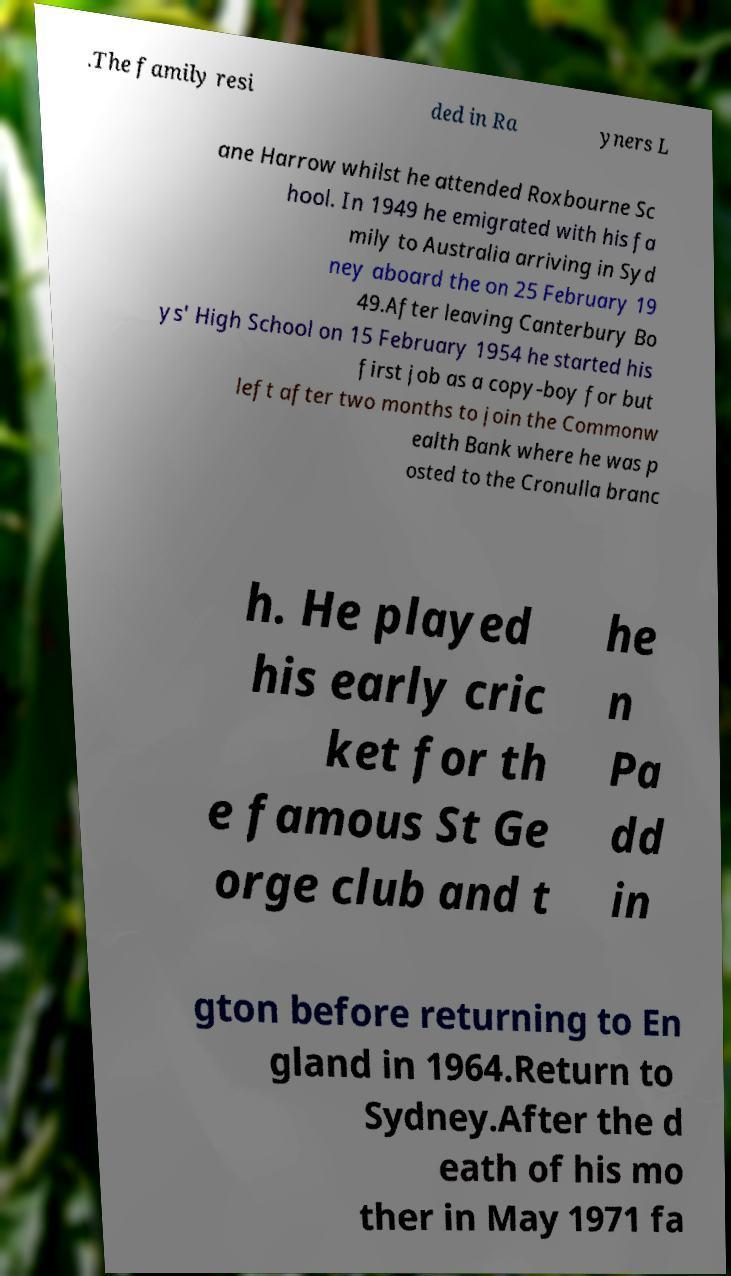What messages or text are displayed in this image? I need them in a readable, typed format. .The family resi ded in Ra yners L ane Harrow whilst he attended Roxbourne Sc hool. In 1949 he emigrated with his fa mily to Australia arriving in Syd ney aboard the on 25 February 19 49.After leaving Canterbury Bo ys' High School on 15 February 1954 he started his first job as a copy-boy for but left after two months to join the Commonw ealth Bank where he was p osted to the Cronulla branc h. He played his early cric ket for th e famous St Ge orge club and t he n Pa dd in gton before returning to En gland in 1964.Return to Sydney.After the d eath of his mo ther in May 1971 fa 